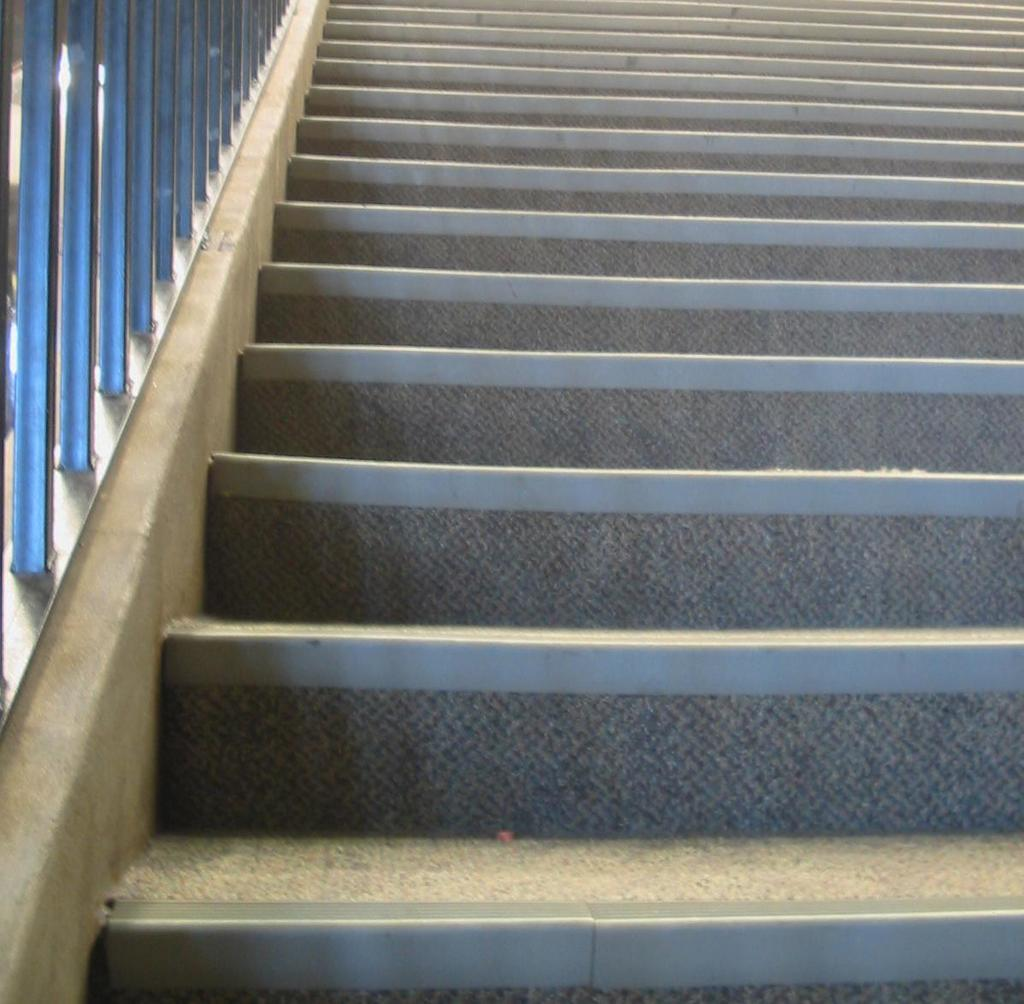What type of structure can be seen in the image? There are stairs in the image. What material are the poles made of in the image? The poles in the image are made of iron. What type of haircut is the person on the stairs getting in the image? There is no person getting a haircut in the image; it only features stairs and iron poles. What scent can be detected from the image? There is no scent present in the image, as it is a visual representation. 